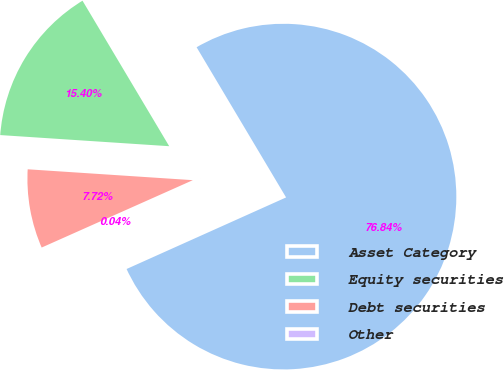<chart> <loc_0><loc_0><loc_500><loc_500><pie_chart><fcel>Asset Category<fcel>Equity securities<fcel>Debt securities<fcel>Other<nl><fcel>76.84%<fcel>15.4%<fcel>7.72%<fcel>0.04%<nl></chart> 